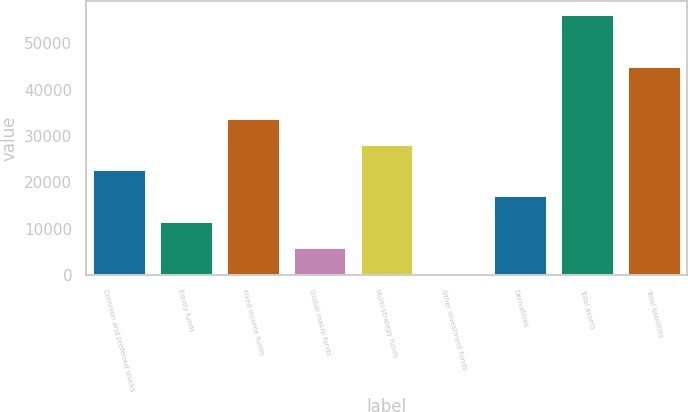Convert chart. <chart><loc_0><loc_0><loc_500><loc_500><bar_chart><fcel>Common and preferred stocks<fcel>Equity funds<fcel>Fixed income funds<fcel>Global macro funds<fcel>Multi-strategy funds<fcel>Other investment funds<fcel>Derivatives<fcel>Total assets<fcel>Total liabilities<nl><fcel>22812.8<fcel>11674.4<fcel>33951.2<fcel>6105.2<fcel>28382<fcel>536<fcel>17243.6<fcel>56239.2<fcel>45089.6<nl></chart> 